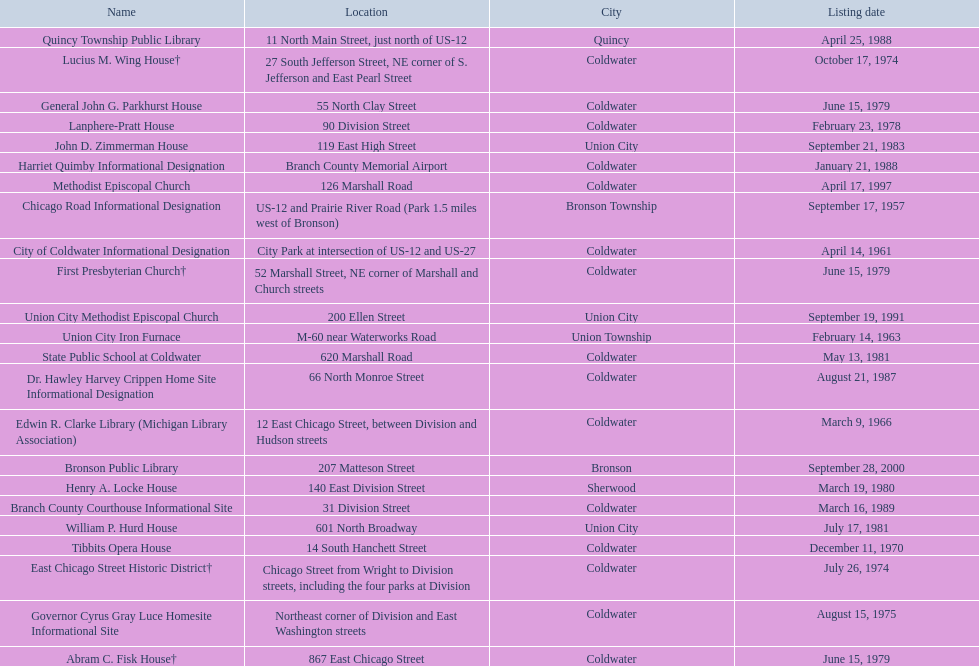Which site was listed earlier, the state public school or the edwin r. clarke library? Edwin R. Clarke Library. 